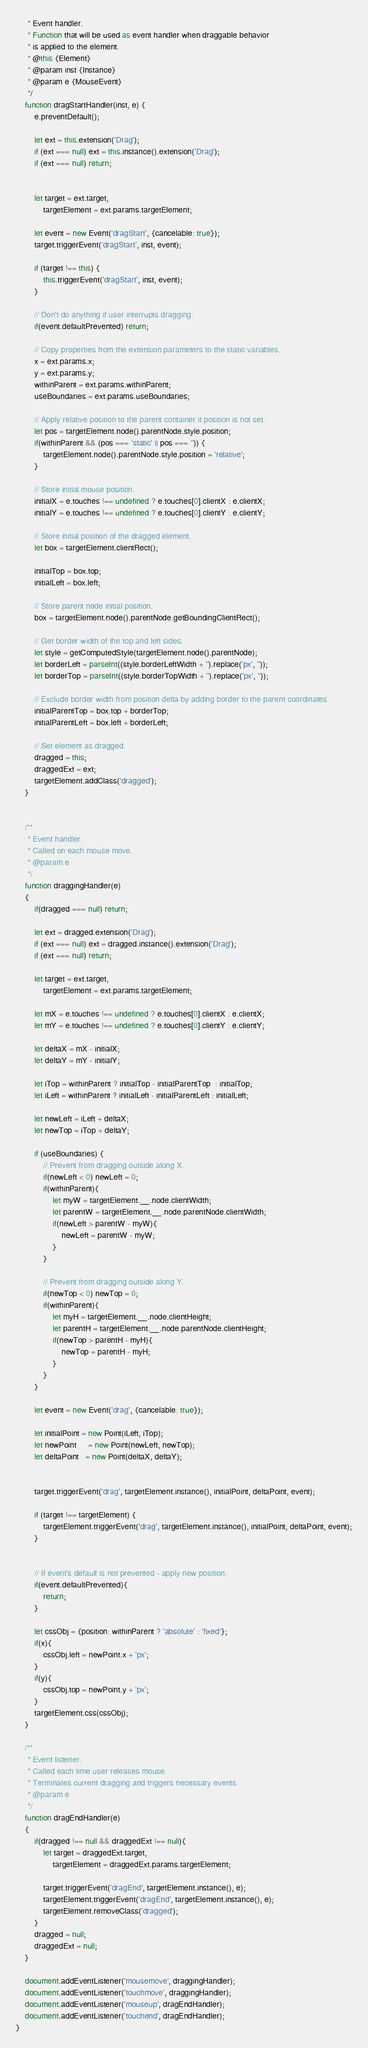<code> <loc_0><loc_0><loc_500><loc_500><_JavaScript_>     * Event handler.
     * Function that will be used as event handler when draggable behavior
     * is applied to the element.
     * @this {Element}
     * @param inst {Instance}
     * @param e {MouseEvent}
     */
    function dragStartHandler(inst, e) {
        e.preventDefault();

        let ext = this.extension('Drag');
        if (ext === null) ext = this.instance().extension('Drag');
        if (ext === null) return;


        let target = ext.target,
            targetElement = ext.params.targetElement;

        let event = new Event('dragStart', {cancelable: true});
        target.triggerEvent('dragStart', inst, event);

        if (target !== this) {
            this.triggerEvent('dragStart', inst, event);
        }

        // Don't do anything if user interrupts dragging.
        if(event.defaultPrevented) return;

        // Copy properties from the extension parameters to the static variables.
        x = ext.params.x;
        y = ext.params.y;
        withinParent = ext.params.withinParent;
        useBoundaries = ext.params.useBoundaries;

        // Apply relative position to the parent container it position is not set.
        let pos = targetElement.node().parentNode.style.position;
        if(withinParent && (pos === 'static' || pos === '')) {
            targetElement.node().parentNode.style.position = 'relative';
        }

        // Store initial mouse position.
        initialX = e.touches !== undefined ? e.touches[0].clientX : e.clientX;
        initialY = e.touches !== undefined ? e.touches[0].clientY : e.clientY;

        // Store initial position of the dragged element.
        let box = targetElement.clientRect();

        initialTop = box.top;
        initialLeft = box.left;

        // Store parent node initial position.
        box = targetElement.node().parentNode.getBoundingClientRect();

        // Get border width of the top and left sides.
        let style = getComputedStyle(targetElement.node().parentNode);
        let borderLeft = parseInt((style.borderLeftWidth + '').replace('px', ''));
        let borderTop = parseInt((style.borderTopWidth + '').replace('px', ''));

        // Exclude border width from position delta by adding border to the parent coordinates.
        initialParentTop = box.top + borderTop;
        initialParentLeft = box.left + borderLeft;

        // Set element as dragged.
        dragged = this;
        draggedExt = ext;
        targetElement.addClass('dragged');
    }


    /**
     * Event handler.
     * Called on each mouse move.
     * @param e
     */
    function draggingHandler(e)
    {
        if(dragged === null) return;

        let ext = dragged.extension('Drag');
        if (ext === null) ext = dragged.instance().extension('Drag');
        if (ext === null) return;

        let target = ext.target,
            targetElement = ext.params.targetElement;

        let mX = e.touches !== undefined ? e.touches[0].clientX : e.clientX;
        let mY = e.touches !== undefined ? e.touches[0].clientY : e.clientY;

        let deltaX = mX - initialX;
        let deltaY = mY - initialY;

        let iTop = withinParent ? initialTop - initialParentTop  : initialTop;
        let iLeft = withinParent ? initialLeft - initialParentLeft : initialLeft;

        let newLeft = iLeft + deltaX;
        let newTop = iTop + deltaY;

        if (useBoundaries) {
            // Prevent from dragging outside along X.
            if(newLeft < 0) newLeft = 0;
            if(withinParent){
                let myW = targetElement.__.node.clientWidth;
                let parentW = targetElement.__.node.parentNode.clientWidth;
                if(newLeft > parentW - myW){
                    newLeft = parentW - myW;
                }
            }

            // Prevent from dragging outside along Y.
            if(newTop < 0) newTop = 0;
            if(withinParent){
                let myH = targetElement.__.node.clientHeight;
                let parentH = targetElement.__.node.parentNode.clientHeight;
                if(newTop > parentH - myH){
                    newTop = parentH - myH;
                }
            }
        }

        let event = new Event('drag', {cancelable: true});

        let initialPoint = new Point(iLeft, iTop);
        let newPoint     = new Point(newLeft, newTop);
        let deltaPoint   = new Point(deltaX, deltaY);


        target.triggerEvent('drag', targetElement.instance(), initialPoint, deltaPoint, event);

        if (target !== targetElement) {
            targetElement.triggerEvent('drag', targetElement.instance(), initialPoint, deltaPoint, event);
        }


        // If event's default is not prevented - apply new position.
        if(event.defaultPrevented){
            return;
        }

        let cssObj = {position: withinParent ? 'absolute' : 'fixed'};
        if(x){
            cssObj.left = newPoint.x + 'px';
        }
        if(y){
            cssObj.top = newPoint.y + 'px';
        }
        targetElement.css(cssObj);
    }

    /**
     * Event listener.
     * Called each time user releases mouse.
     * Terminates current dragging and triggers necessary events.
     * @param e
     */
    function dragEndHandler(e)
    {
        if(dragged !== null && draggedExt !== null){
            let target = draggedExt.target,
                targetElement = draggedExt.params.targetElement;

            target.triggerEvent('dragEnd', targetElement.instance(), e);
            targetElement.triggerEvent('dragEnd', targetElement.instance(), e);
            targetElement.removeClass('dragged');
        }
        dragged = null;
        draggedExt = null;
    }

    document.addEventListener('mousemove', draggingHandler);
    document.addEventListener('touchmove', draggingHandler);
    document.addEventListener('mouseup', dragEndHandler);
    document.addEventListener('touchend', dragEndHandler);
}




</code> 